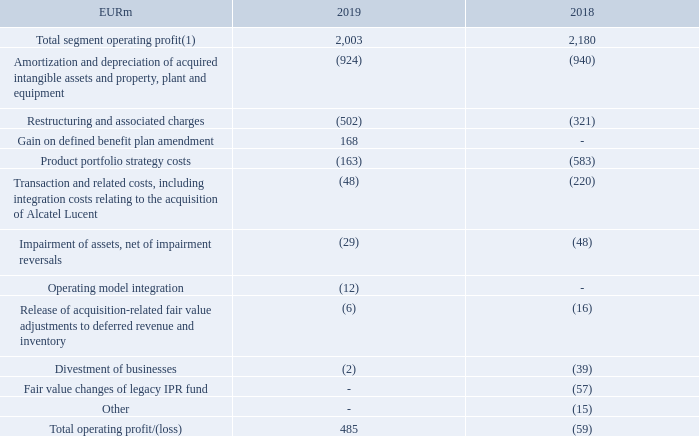Operating profit/loss
Our operating profit in 2019 was EUR 485 million, a change of EUR 544 million, compared to an operating loss of EUR 59 million in 2018. The change in operating result was primarily due to lower selling, general and administrative expenses, research and development expenses and a net positive fluctuation in other operating income and expenses, partially offset by lower gross profit. Our operating margin in 2019 was 2.1%, compared to approximately breakeven in 2018.
(1) Excludes costs related to the acquisition of Alcatel Lucent and related integration, goodwill impairment charges, intangible asset amortization and other purchase price fair value adjustments, restructuring and associated charges and certain other items.
The following table sets forth the impact of unallocated items on operating profit/loss:
What was the rationale for change in operating profit / (loss)? The change in operating result was primarily due to lower selling, general and administrative expenses, research and development expenses and a net positive fluctuation in other operating income and expenses, partially offset by lower gross profit. What was the divestment of business in 2019?
Answer scale should be: million. (2). What is excluded from Total segment operating profit? Costs related to the acquisition of alcatel lucent and related integration, goodwill impairment charges, intangible asset amortization and other purchase price fair value adjustments, restructuring and associated charges and certain other items. What is the increase / (decrease) in the Total segment operating profit(1) from 2018 to 2019?
Answer scale should be: million. 2,003 - 2,180
Answer: -177. What is the average Restructuring and associated charges?
Answer scale should be: million. -(502 + 321) / 2
Answer: -411.5. What percentage of total operating profit / (loss) is Divestment of businesses in 2019?
Answer scale should be: percent. (2) / 485
Answer: -0.41. 